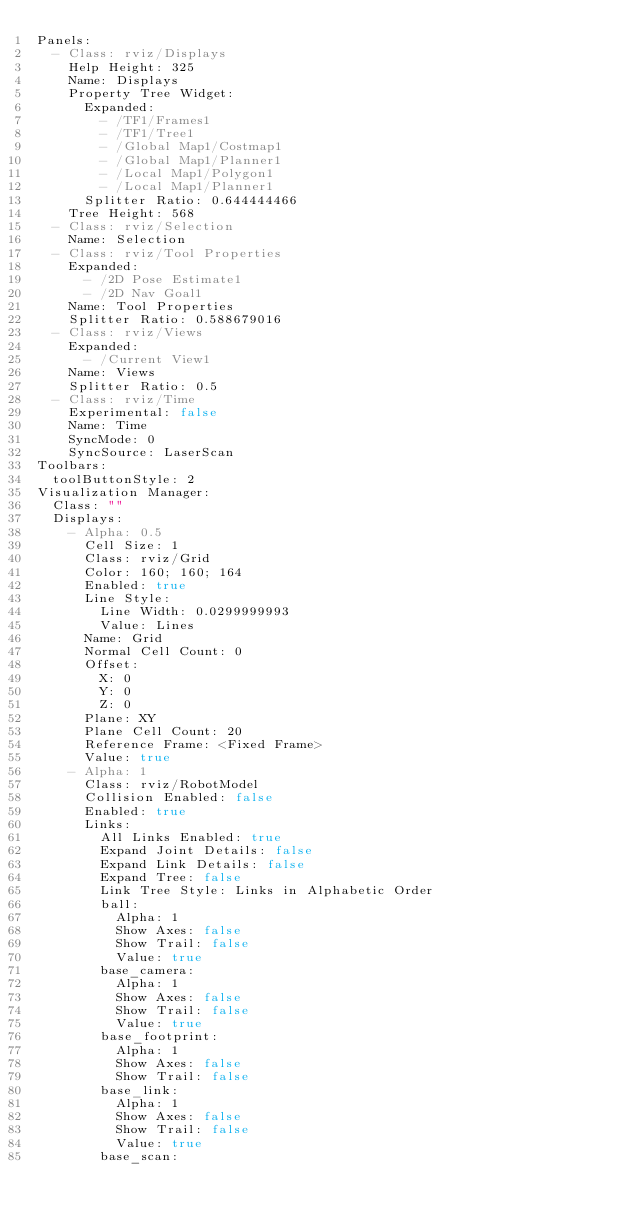Convert code to text. <code><loc_0><loc_0><loc_500><loc_500><_YAML_>Panels:
  - Class: rviz/Displays
    Help Height: 325
    Name: Displays
    Property Tree Widget:
      Expanded:
        - /TF1/Frames1
        - /TF1/Tree1
        - /Global Map1/Costmap1
        - /Global Map1/Planner1
        - /Local Map1/Polygon1
        - /Local Map1/Planner1
      Splitter Ratio: 0.644444466
    Tree Height: 568
  - Class: rviz/Selection
    Name: Selection
  - Class: rviz/Tool Properties
    Expanded:
      - /2D Pose Estimate1
      - /2D Nav Goal1
    Name: Tool Properties
    Splitter Ratio: 0.588679016
  - Class: rviz/Views
    Expanded:
      - /Current View1
    Name: Views
    Splitter Ratio: 0.5
  - Class: rviz/Time
    Experimental: false
    Name: Time
    SyncMode: 0
    SyncSource: LaserScan
Toolbars:
  toolButtonStyle: 2
Visualization Manager:
  Class: ""
  Displays:
    - Alpha: 0.5
      Cell Size: 1
      Class: rviz/Grid
      Color: 160; 160; 164
      Enabled: true
      Line Style:
        Line Width: 0.0299999993
        Value: Lines
      Name: Grid
      Normal Cell Count: 0
      Offset:
        X: 0
        Y: 0
        Z: 0
      Plane: XY
      Plane Cell Count: 20
      Reference Frame: <Fixed Frame>
      Value: true
    - Alpha: 1
      Class: rviz/RobotModel
      Collision Enabled: false
      Enabled: true
      Links:
        All Links Enabled: true
        Expand Joint Details: false
        Expand Link Details: false
        Expand Tree: false
        Link Tree Style: Links in Alphabetic Order
        ball:
          Alpha: 1
          Show Axes: false
          Show Trail: false
          Value: true
        base_camera:
          Alpha: 1
          Show Axes: false
          Show Trail: false
          Value: true
        base_footprint:
          Alpha: 1
          Show Axes: false
          Show Trail: false
        base_link:
          Alpha: 1
          Show Axes: false
          Show Trail: false
          Value: true
        base_scan:</code> 